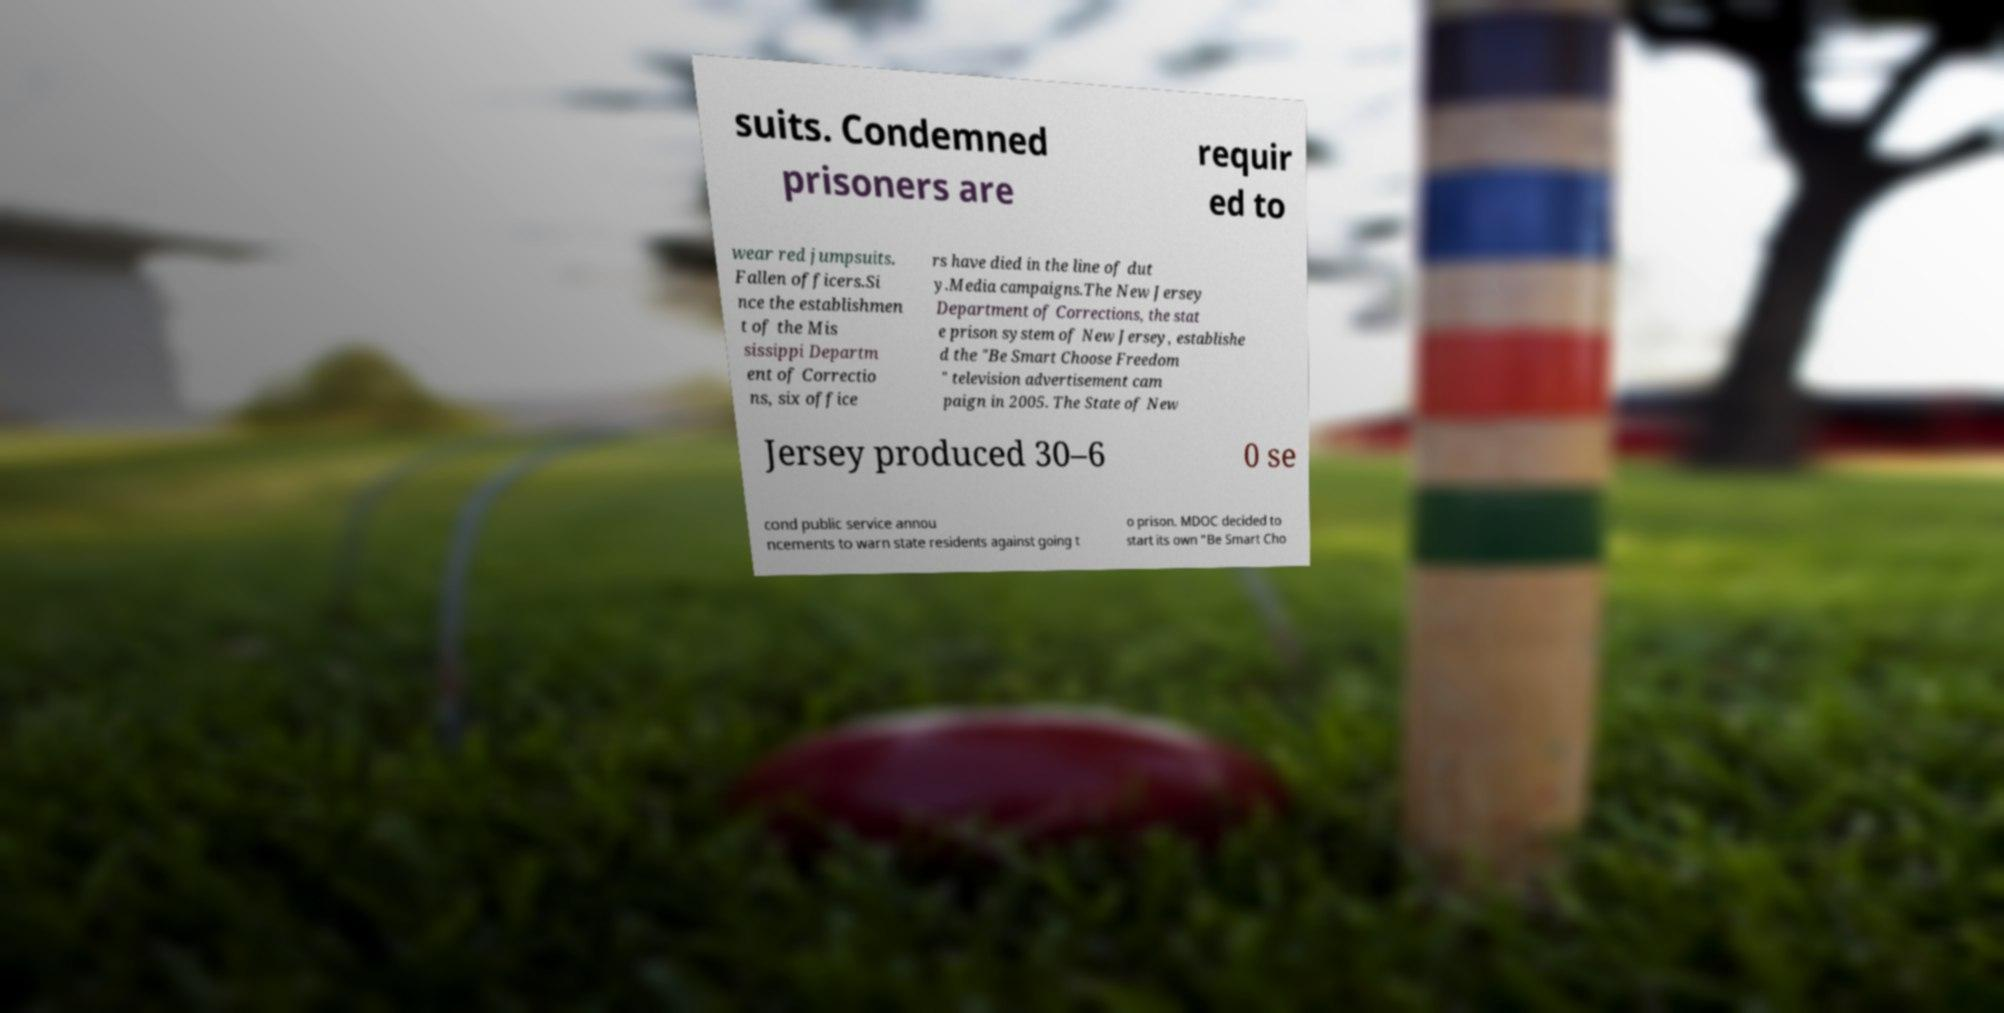Please identify and transcribe the text found in this image. suits. Condemned prisoners are requir ed to wear red jumpsuits. Fallen officers.Si nce the establishmen t of the Mis sissippi Departm ent of Correctio ns, six office rs have died in the line of dut y.Media campaigns.The New Jersey Department of Corrections, the stat e prison system of New Jersey, establishe d the "Be Smart Choose Freedom " television advertisement cam paign in 2005. The State of New Jersey produced 30–6 0 se cond public service annou ncements to warn state residents against going t o prison. MDOC decided to start its own "Be Smart Cho 